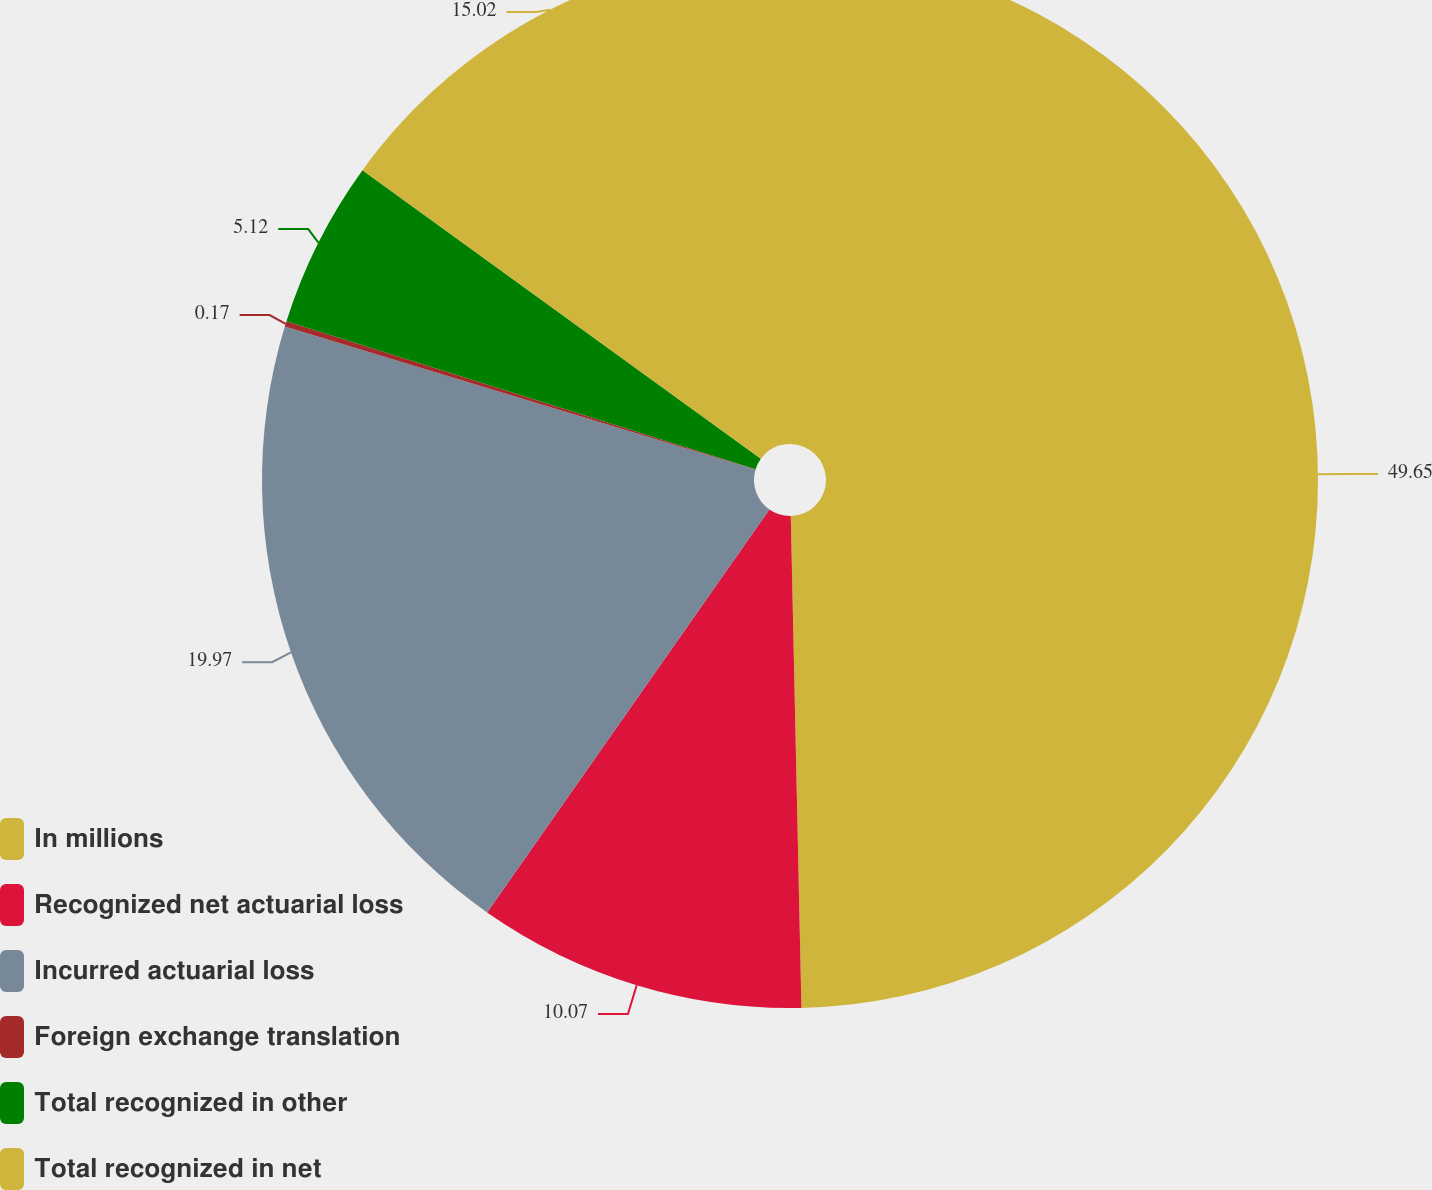Convert chart to OTSL. <chart><loc_0><loc_0><loc_500><loc_500><pie_chart><fcel>In millions<fcel>Recognized net actuarial loss<fcel>Incurred actuarial loss<fcel>Foreign exchange translation<fcel>Total recognized in other<fcel>Total recognized in net<nl><fcel>49.66%<fcel>10.07%<fcel>19.97%<fcel>0.17%<fcel>5.12%<fcel>15.02%<nl></chart> 